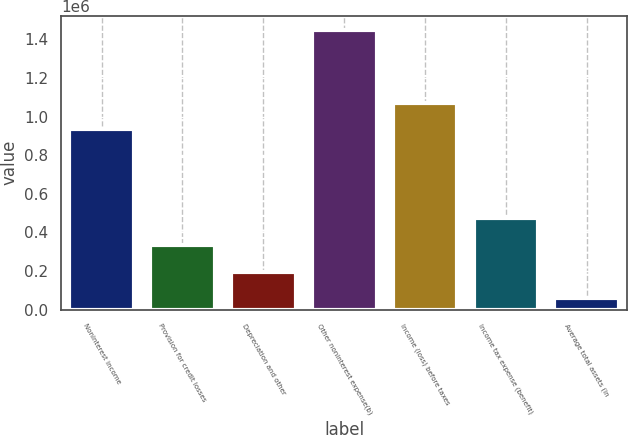<chart> <loc_0><loc_0><loc_500><loc_500><bar_chart><fcel>Noninterest income<fcel>Provision for credit losses<fcel>Depreciation and other<fcel>Other noninterest expense(b)<fcel>Income (loss) before taxes<fcel>Income tax expense (benefit)<fcel>Average total assets (in<nl><fcel>932989<fcel>336742<fcel>197644<fcel>1.44953e+06<fcel>1.07209e+06<fcel>475840<fcel>58545<nl></chart> 